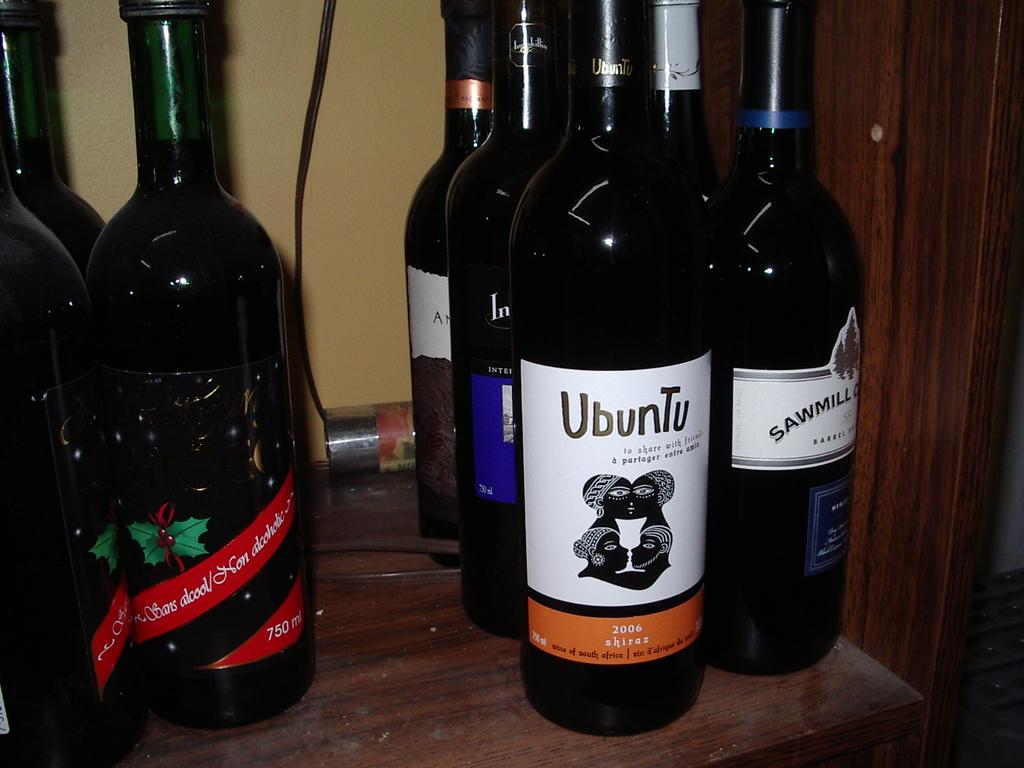<image>
Render a clear and concise summary of the photo. An Ubuntu labeled bottle surrounded by several others...... 